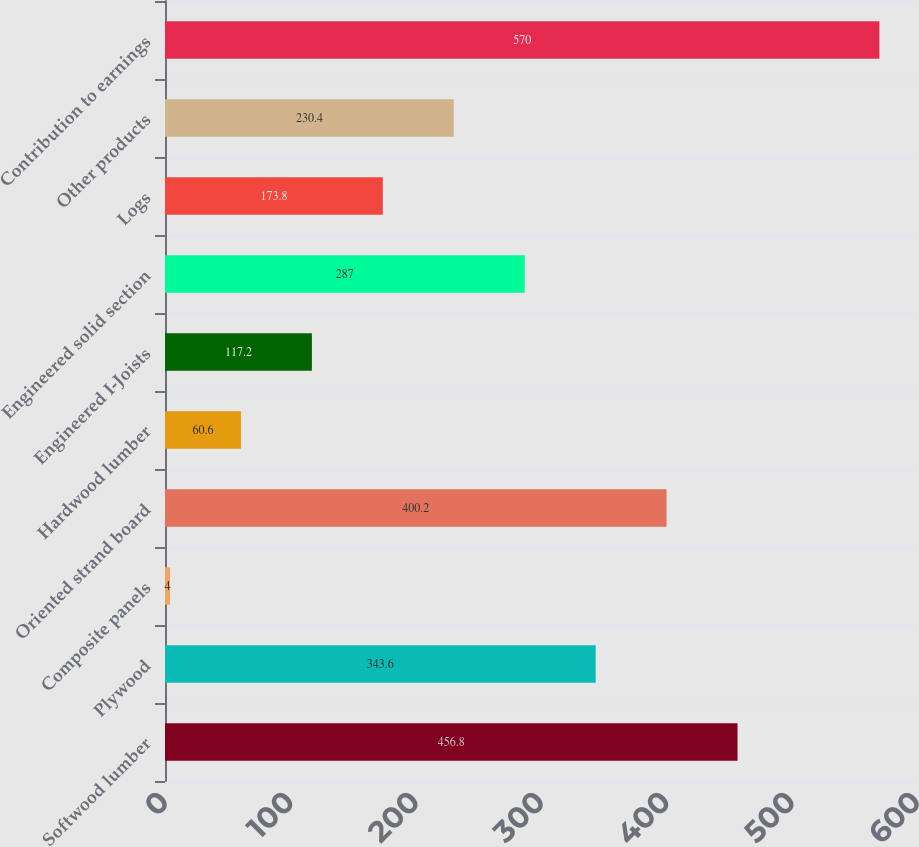Convert chart. <chart><loc_0><loc_0><loc_500><loc_500><bar_chart><fcel>Softwood lumber<fcel>Plywood<fcel>Composite panels<fcel>Oriented strand board<fcel>Hardwood lumber<fcel>Engineered I-Joists<fcel>Engineered solid section<fcel>Logs<fcel>Other products<fcel>Contribution to earnings<nl><fcel>456.8<fcel>343.6<fcel>4<fcel>400.2<fcel>60.6<fcel>117.2<fcel>287<fcel>173.8<fcel>230.4<fcel>570<nl></chart> 